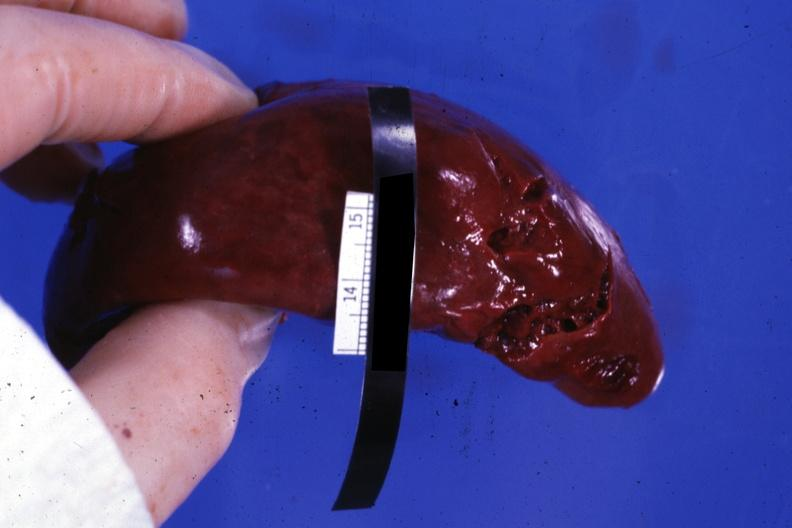does this image show external view with several tears in capsule?
Answer the question using a single word or phrase. Yes 